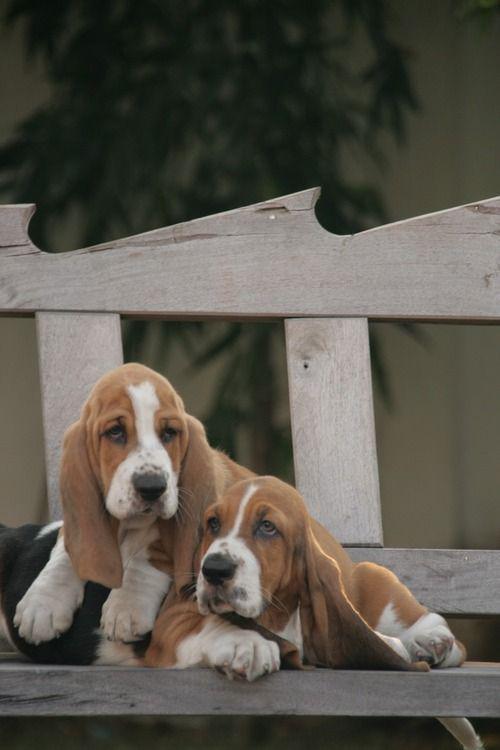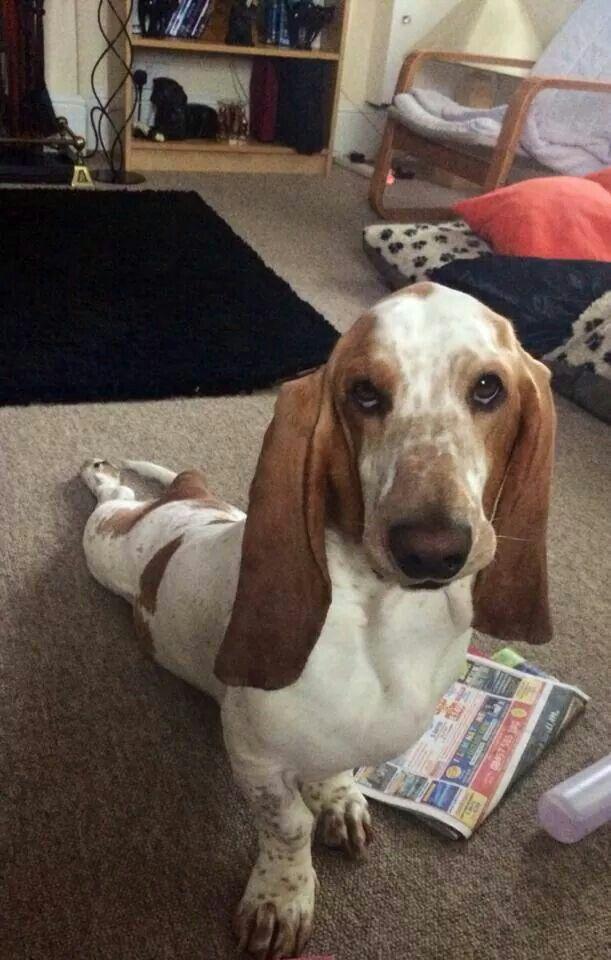The first image is the image on the left, the second image is the image on the right. For the images shown, is this caption "There is at least two dogs in the right image." true? Answer yes or no. No. The first image is the image on the left, the second image is the image on the right. Given the left and right images, does the statement "At least one of the dogs is lying down with its belly on the floor." hold true? Answer yes or no. Yes. 